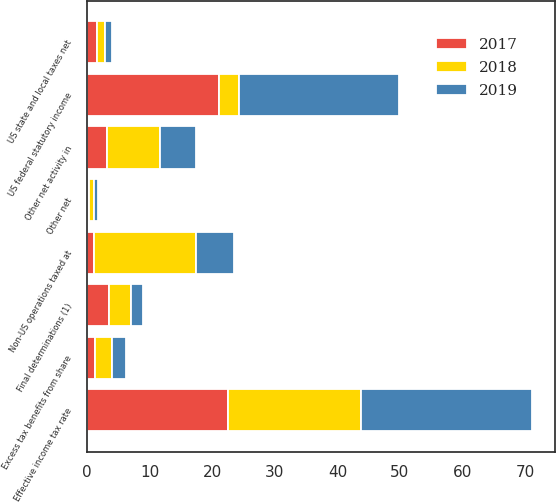<chart> <loc_0><loc_0><loc_500><loc_500><stacked_bar_chart><ecel><fcel>US federal statutory income<fcel>US state and local taxes net<fcel>Non-US operations taxed at<fcel>Final determinations (1)<fcel>Other net activity in<fcel>Excess tax benefits from share<fcel>Other net<fcel>Effective income tax rate<nl><fcel>2017<fcel>21<fcel>1.5<fcel>1.1<fcel>3.4<fcel>3.2<fcel>1.2<fcel>0.3<fcel>22.5<nl><fcel>2019<fcel>25.7<fcel>1.1<fcel>6.1<fcel>1.9<fcel>5.8<fcel>2.3<fcel>0.7<fcel>27.4<nl><fcel>2018<fcel>3.2<fcel>1.3<fcel>16.3<fcel>3.6<fcel>8.4<fcel>2.7<fcel>0.7<fcel>21.3<nl></chart> 